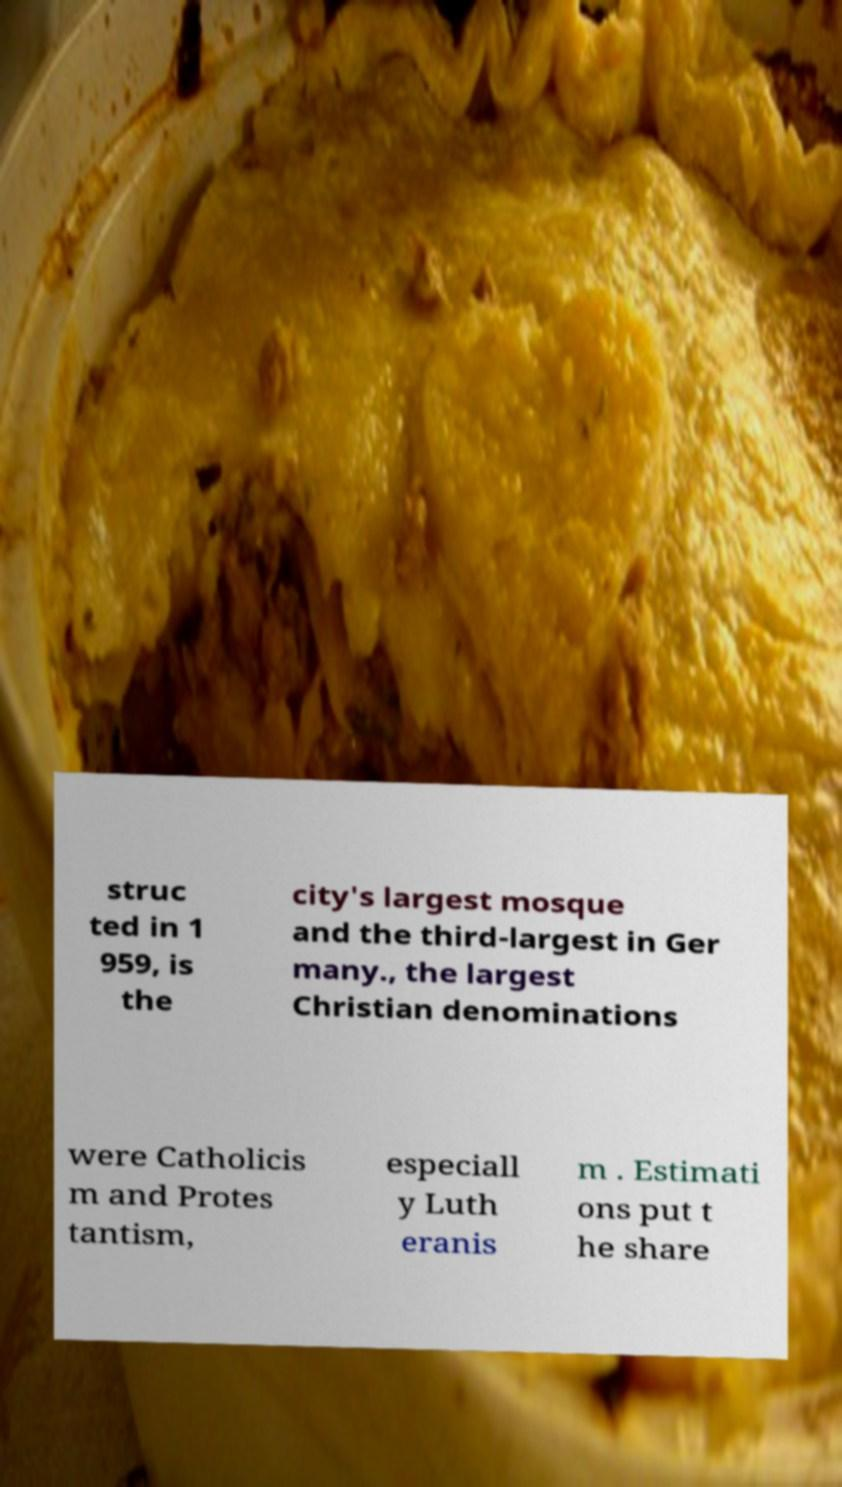What messages or text are displayed in this image? I need them in a readable, typed format. struc ted in 1 959, is the city's largest mosque and the third-largest in Ger many., the largest Christian denominations were Catholicis m and Protes tantism, especiall y Luth eranis m . Estimati ons put t he share 